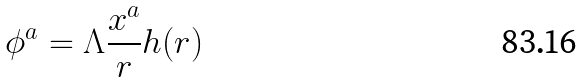<formula> <loc_0><loc_0><loc_500><loc_500>\phi ^ { a } = \Lambda \frac { x ^ { a } } { r } h ( r )</formula> 